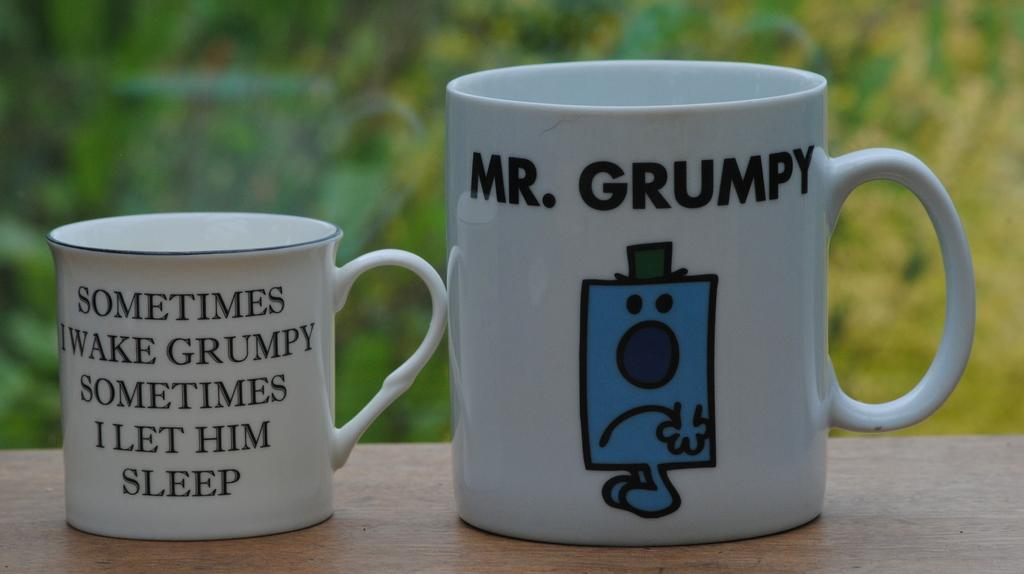<image>
Relay a brief, clear account of the picture shown. a cup that has the word Mr. Grumpy on it 